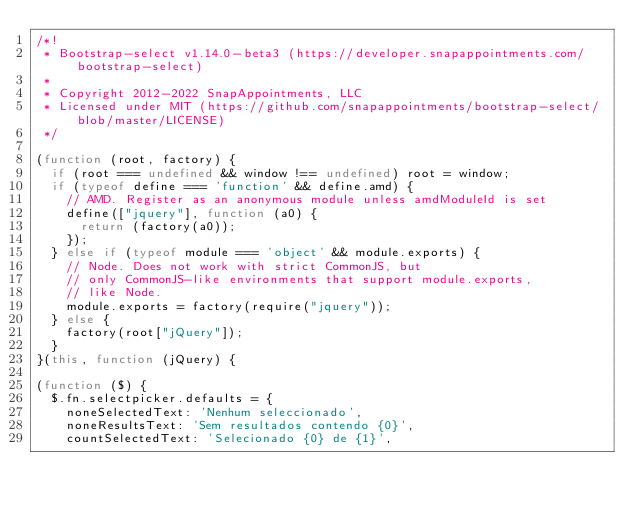<code> <loc_0><loc_0><loc_500><loc_500><_JavaScript_>/*!
 * Bootstrap-select v1.14.0-beta3 (https://developer.snapappointments.com/bootstrap-select)
 *
 * Copyright 2012-2022 SnapAppointments, LLC
 * Licensed under MIT (https://github.com/snapappointments/bootstrap-select/blob/master/LICENSE)
 */

(function (root, factory) {
  if (root === undefined && window !== undefined) root = window;
  if (typeof define === 'function' && define.amd) {
    // AMD. Register as an anonymous module unless amdModuleId is set
    define(["jquery"], function (a0) {
      return (factory(a0));
    });
  } else if (typeof module === 'object' && module.exports) {
    // Node. Does not work with strict CommonJS, but
    // only CommonJS-like environments that support module.exports,
    // like Node.
    module.exports = factory(require("jquery"));
  } else {
    factory(root["jQuery"]);
  }
}(this, function (jQuery) {

(function ($) {
  $.fn.selectpicker.defaults = {
    noneSelectedText: 'Nenhum seleccionado',
    noneResultsText: 'Sem resultados contendo {0}',
    countSelectedText: 'Selecionado {0} de {1}',</code> 